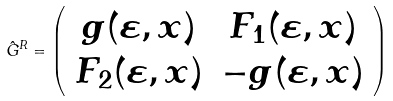Convert formula to latex. <formula><loc_0><loc_0><loc_500><loc_500>\hat { G } ^ { R } = \left ( \begin{array} { c c } g ( \varepsilon , x ) & F _ { 1 } ( \varepsilon , x ) \\ F _ { 2 } ( \varepsilon , x ) & - g ( \varepsilon , x ) \\ \end{array} \right )</formula> 